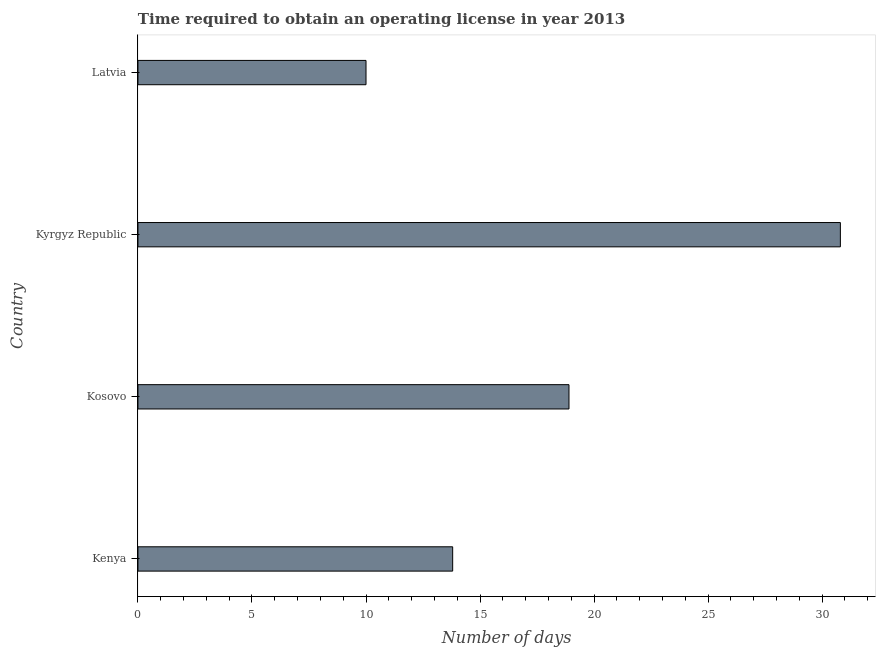Does the graph contain any zero values?
Provide a succinct answer. No. What is the title of the graph?
Provide a short and direct response. Time required to obtain an operating license in year 2013. What is the label or title of the X-axis?
Give a very brief answer. Number of days. Across all countries, what is the maximum number of days to obtain operating license?
Give a very brief answer. 30.8. In which country was the number of days to obtain operating license maximum?
Provide a succinct answer. Kyrgyz Republic. In which country was the number of days to obtain operating license minimum?
Make the answer very short. Latvia. What is the sum of the number of days to obtain operating license?
Your answer should be compact. 73.5. What is the difference between the number of days to obtain operating license in Kyrgyz Republic and Latvia?
Give a very brief answer. 20.8. What is the average number of days to obtain operating license per country?
Your response must be concise. 18.38. What is the median number of days to obtain operating license?
Give a very brief answer. 16.35. In how many countries, is the number of days to obtain operating license greater than 4 days?
Your answer should be very brief. 4. What is the ratio of the number of days to obtain operating license in Kosovo to that in Kyrgyz Republic?
Make the answer very short. 0.61. What is the difference between the highest and the second highest number of days to obtain operating license?
Keep it short and to the point. 11.9. Is the sum of the number of days to obtain operating license in Kosovo and Latvia greater than the maximum number of days to obtain operating license across all countries?
Ensure brevity in your answer.  No. What is the difference between the highest and the lowest number of days to obtain operating license?
Make the answer very short. 20.8. How many bars are there?
Your response must be concise. 4. What is the difference between two consecutive major ticks on the X-axis?
Your answer should be compact. 5. Are the values on the major ticks of X-axis written in scientific E-notation?
Provide a short and direct response. No. What is the Number of days of Kosovo?
Give a very brief answer. 18.9. What is the Number of days of Kyrgyz Republic?
Provide a short and direct response. 30.8. What is the Number of days in Latvia?
Provide a short and direct response. 10. What is the difference between the Number of days in Kenya and Kyrgyz Republic?
Provide a succinct answer. -17. What is the difference between the Number of days in Kenya and Latvia?
Your answer should be compact. 3.8. What is the difference between the Number of days in Kyrgyz Republic and Latvia?
Offer a terse response. 20.8. What is the ratio of the Number of days in Kenya to that in Kosovo?
Your answer should be compact. 0.73. What is the ratio of the Number of days in Kenya to that in Kyrgyz Republic?
Your answer should be very brief. 0.45. What is the ratio of the Number of days in Kenya to that in Latvia?
Provide a short and direct response. 1.38. What is the ratio of the Number of days in Kosovo to that in Kyrgyz Republic?
Your answer should be very brief. 0.61. What is the ratio of the Number of days in Kosovo to that in Latvia?
Offer a very short reply. 1.89. What is the ratio of the Number of days in Kyrgyz Republic to that in Latvia?
Your answer should be very brief. 3.08. 